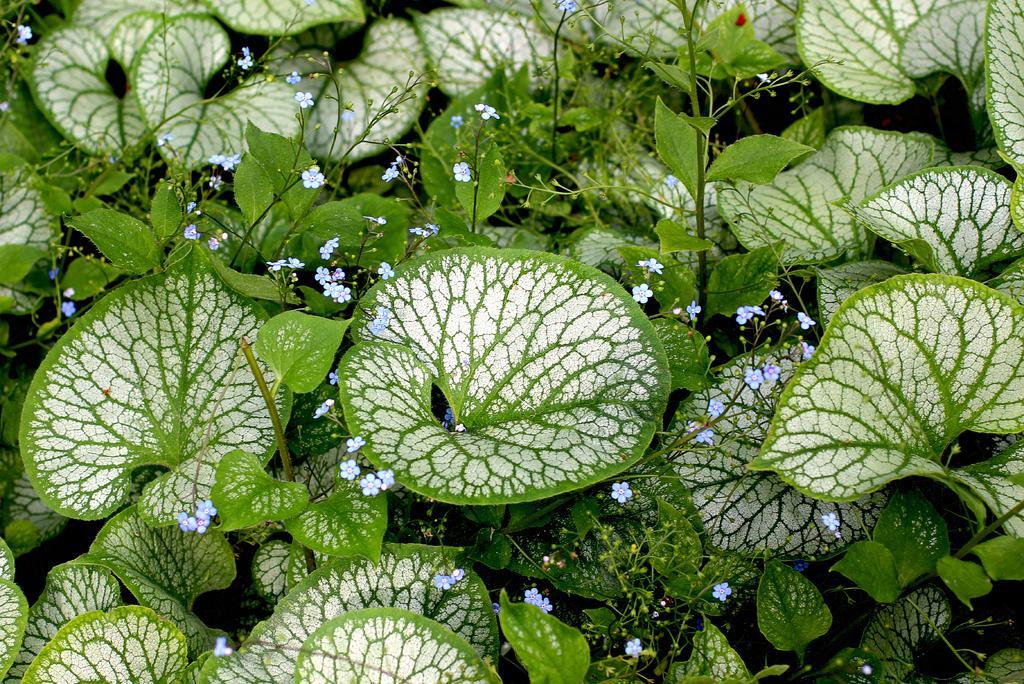Please provide a concise description of this image. There are plants having blue color flowers, green color leaves and white and green color combination leaves. And the background is dark in color. 